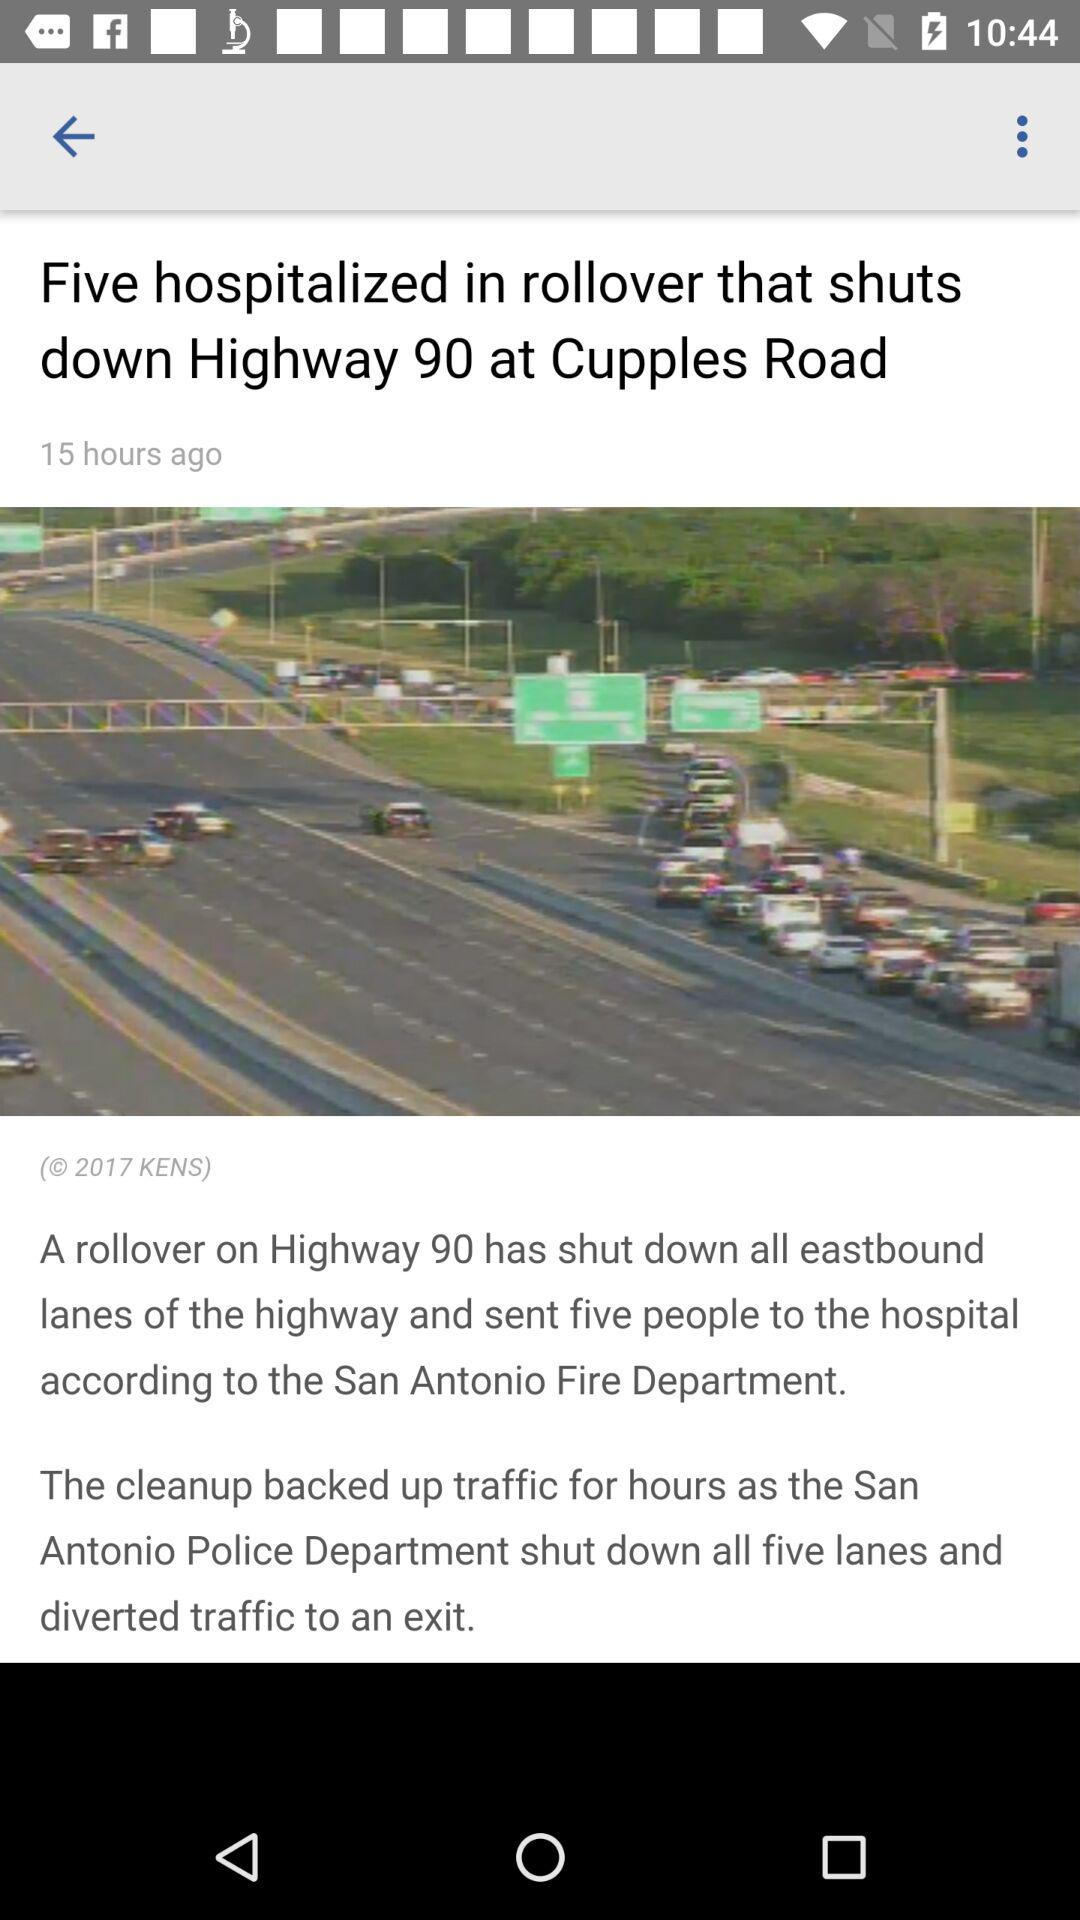How many people are hospitalised in rollovers on Highway 90? The number of people who are hospitalised in rollovers on Highway 90 is five. 